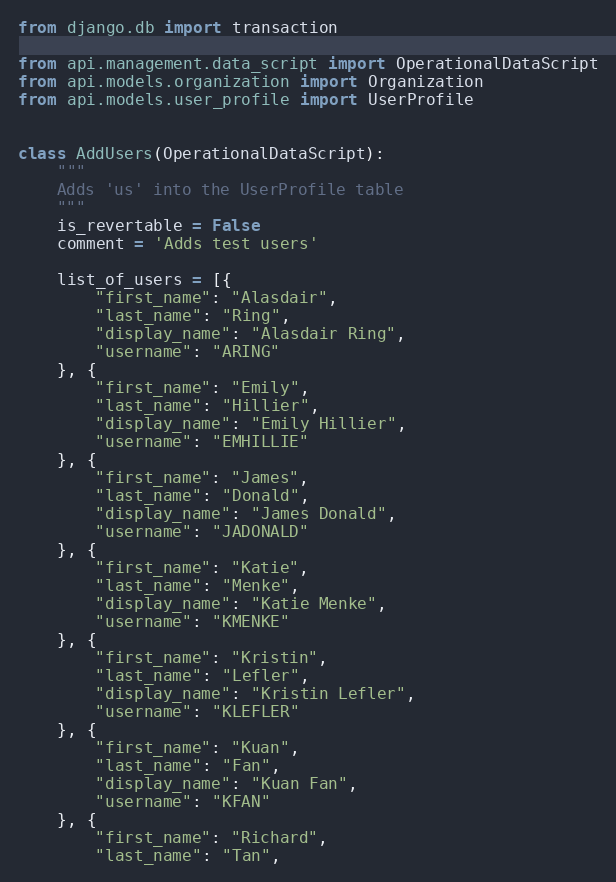<code> <loc_0><loc_0><loc_500><loc_500><_Python_>from django.db import transaction

from api.management.data_script import OperationalDataScript
from api.models.organization import Organization
from api.models.user_profile import UserProfile


class AddUsers(OperationalDataScript):
    """
    Adds 'us' into the UserProfile table
    """
    is_revertable = False
    comment = 'Adds test users'

    list_of_users = [{
        "first_name": "Alasdair",
        "last_name": "Ring",
        "display_name": "Alasdair Ring",
        "username": "ARING"
    }, {
        "first_name": "Emily",
        "last_name": "Hillier",
        "display_name": "Emily Hillier",
        "username": "EMHILLIE"
    }, {
        "first_name": "James",
        "last_name": "Donald",
        "display_name": "James Donald",
        "username": "JADONALD"
    }, {
        "first_name": "Katie",
        "last_name": "Menke",
        "display_name": "Katie Menke",
        "username": "KMENKE"
    }, {
        "first_name": "Kristin",
        "last_name": "Lefler",
        "display_name": "Kristin Lefler",
        "username": "KLEFLER"
    }, {
        "first_name": "Kuan",
        "last_name": "Fan",
        "display_name": "Kuan Fan",
        "username": "KFAN"
    }, {
        "first_name": "Richard",
        "last_name": "Tan",</code> 